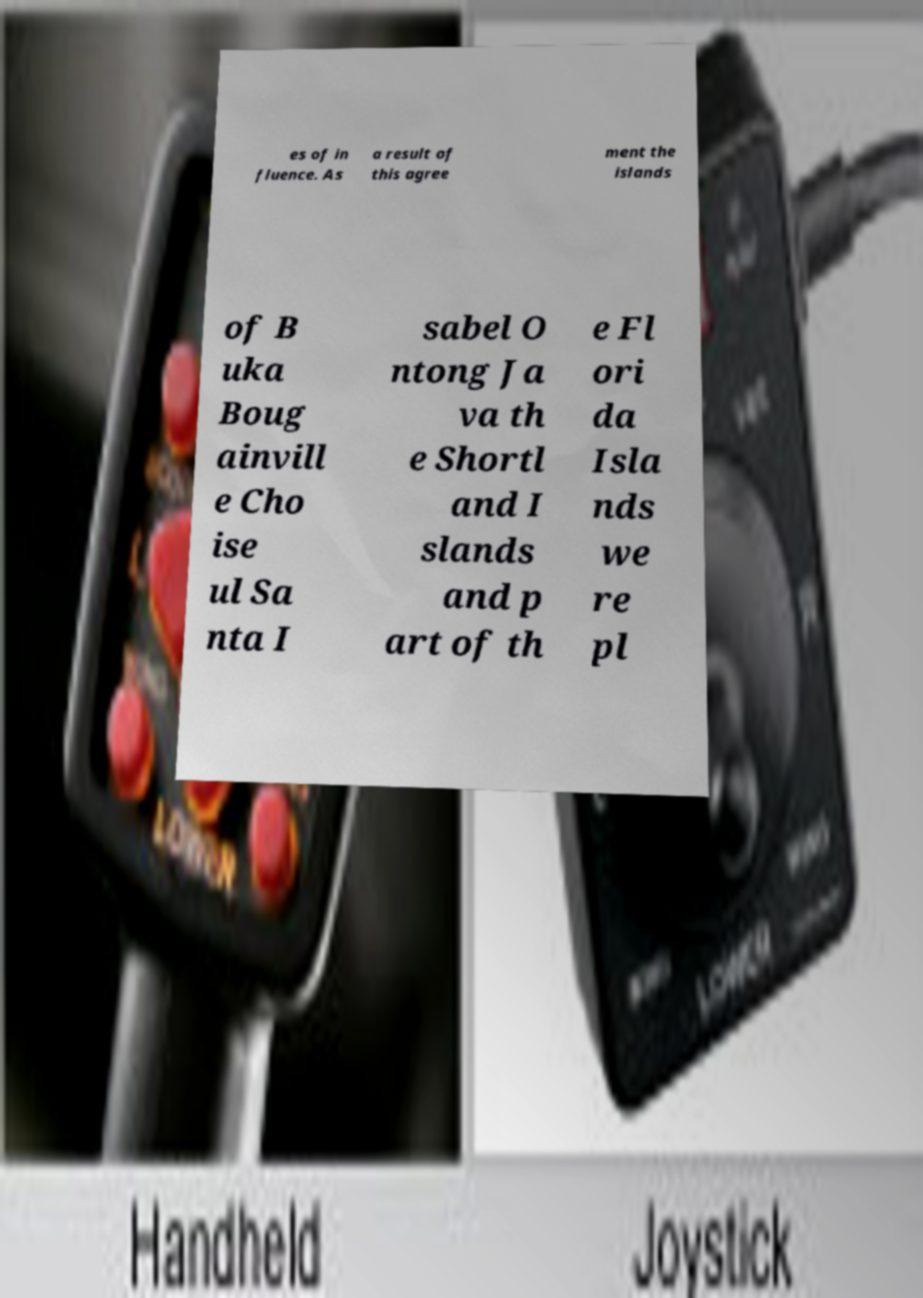Please read and relay the text visible in this image. What does it say? es of in fluence. As a result of this agree ment the islands of B uka Boug ainvill e Cho ise ul Sa nta I sabel O ntong Ja va th e Shortl and I slands and p art of th e Fl ori da Isla nds we re pl 